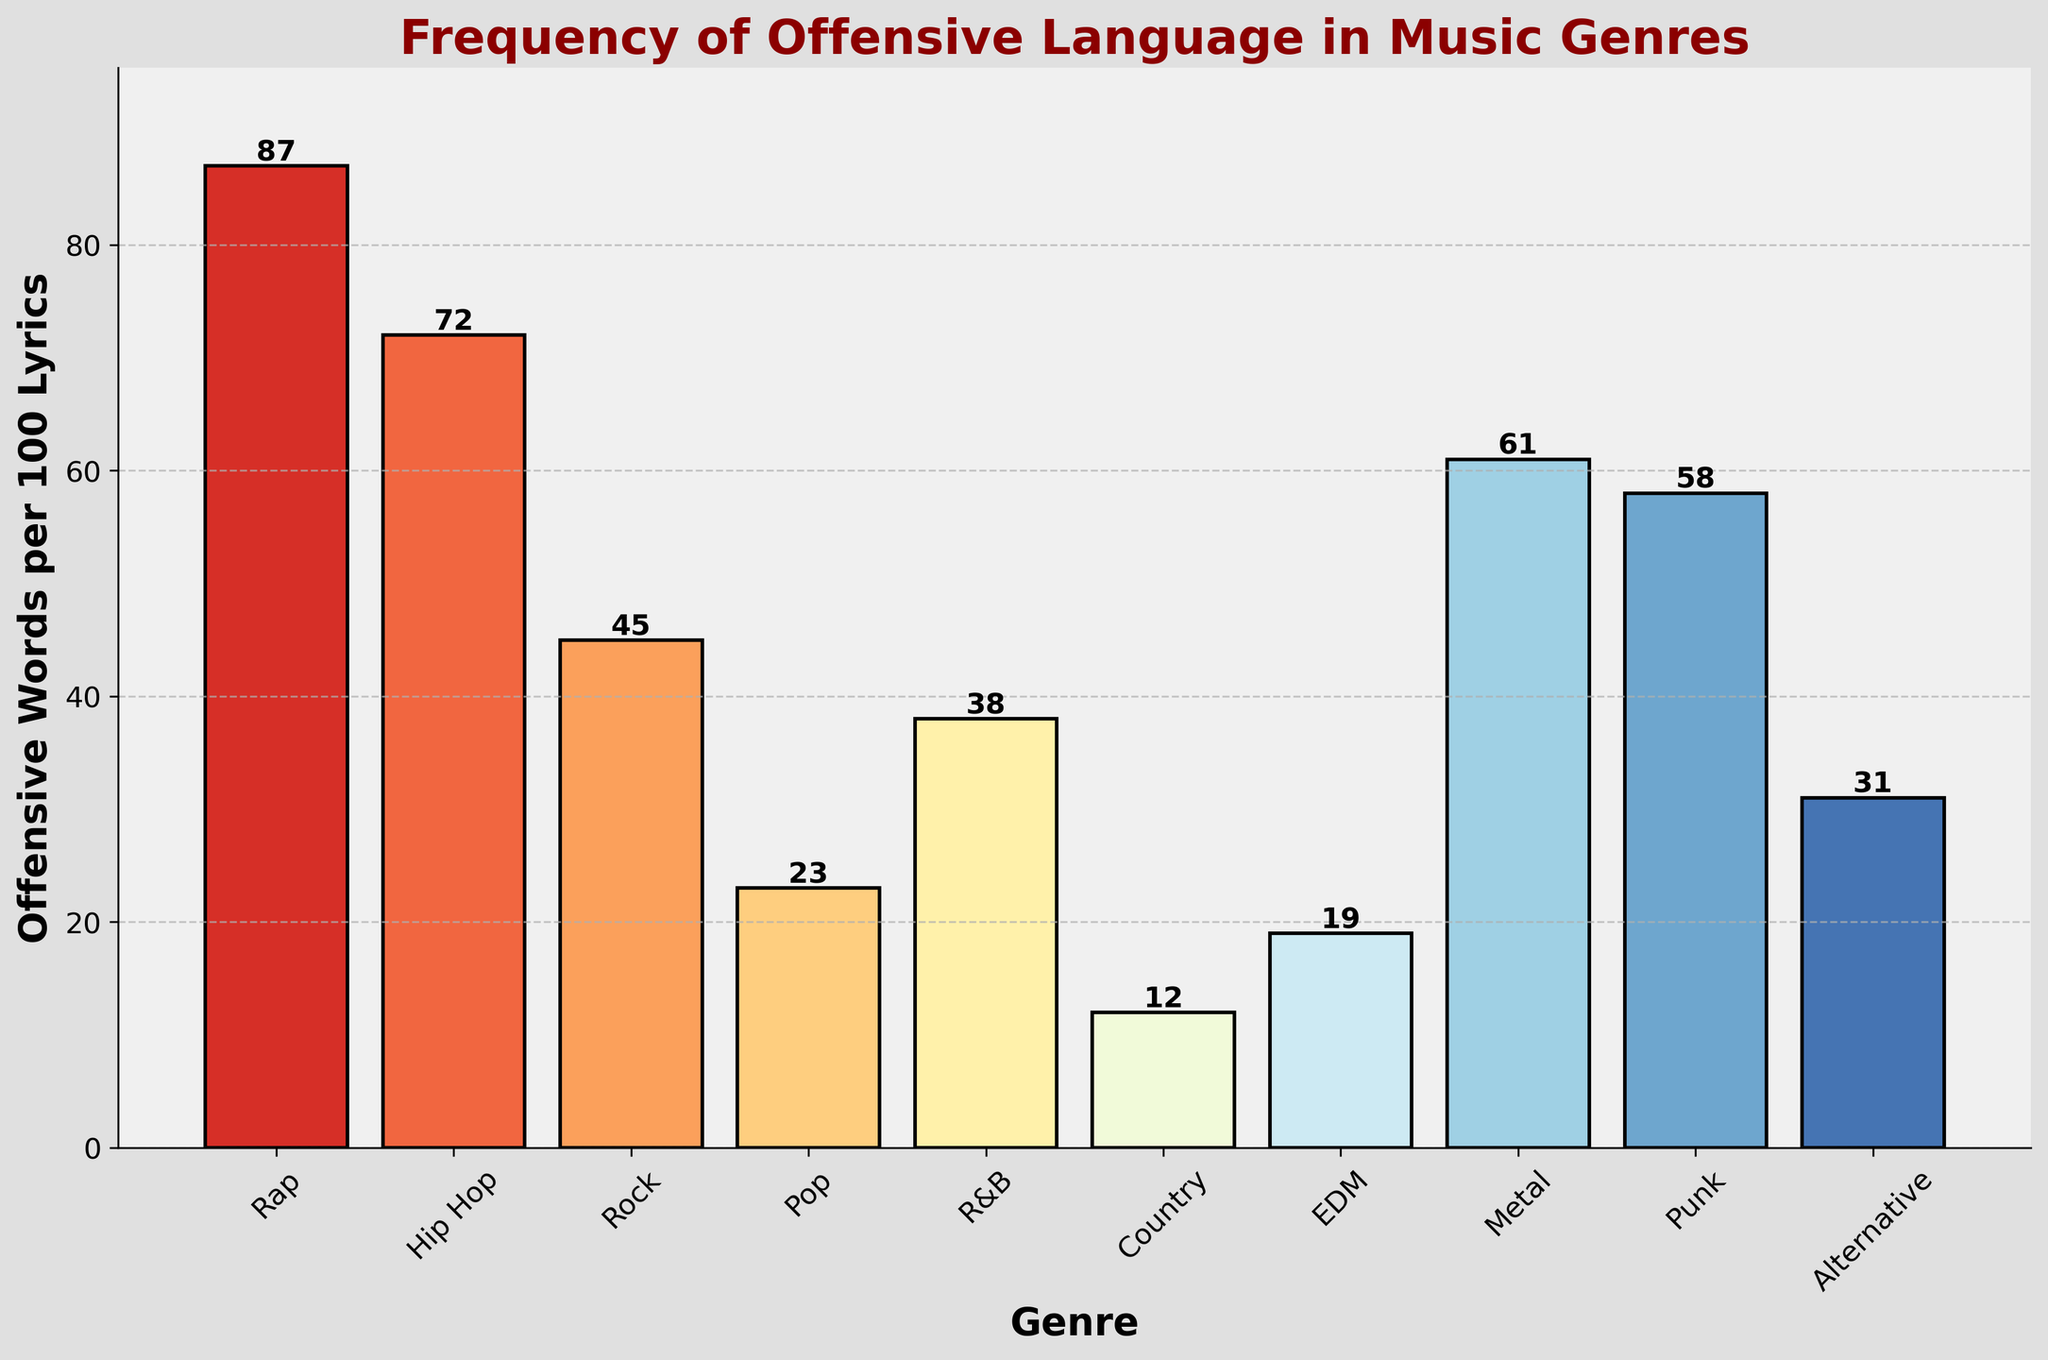Which genre has the highest frequency of offensive language? Look at the genre with the tallest bar. Rap has the highest bar height, indicating the most offensive words per 100 lyrics.
Answer: Rap Which genre has the lowest frequency of offensive language? Identify the genre with the shortest bar. Country has the shortest bar, which represents the lowest frequency of offensive words per 100 lyrics.
Answer: Country How does the frequency of offensive language in Metal compare to that in Rock? Compare the heights of the bars for Metal and Rock. Metal's bar is higher than Rock's bar, indicating Metal has a higher frequency of offensive language.
Answer: Metal has more offensive language What is the total frequency of offensive language for Pop, EDM, and Country combined? Add the values for each genre: Pop (23), EDM (19), Country (12). The sum is 23 + 19 + 12 = 54.
Answer: 54 Which two genres have the most similar frequency of offensive language usage? Find two bars with similar heights. Punk (58) and Metal (61) have the most similar heights, indicating similar frequencies.
Answer: Punk and Metal Is the frequency of offensive language in Hip Hop greater than that in Rock and R&B combined? Hip Hop has 72 offensive words, Rock has 45, and R&B has 38. Sum Rock and R&B: 45 + 38 = 83. Hip Hop's frequency (72) is less than 83.
Answer: No What is the average frequency of offensive language in Alternative, Pop, and R&B? Calculate the average: (31 + 23 + 38) / 3 = 92 / 3 ≈ 30.67.
Answer: 30.67 Which genre between Punk and Alternative has more offensive language? Compare the heights of the bars for Punk and Alternative. Punk's bar is taller than Alternative's bar.
Answer: Punk Which three genres have intermediate frequencies of offensive language between 30 and 60 offensive words per 100 lyrics? Identify the genres with bar heights within this range. Rock (45), R&B (38), and Alternative (31) fall into this range.
Answer: Rock, R&B, Alternative 